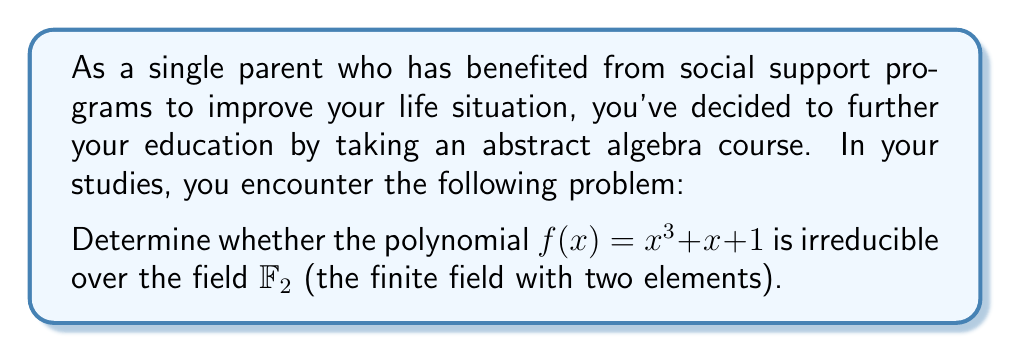Help me with this question. To determine if the polynomial $f(x) = x^3 + x + 1$ is irreducible over $\mathbb{F}_2$, we can follow these steps:

1) First, recall that a polynomial of degree 3 is reducible over a field if and only if it has a root in that field.

2) In $\mathbb{F}_2$, there are only two elements: 0 and 1. We need to check if either of these is a root of $f(x)$.

3) Let's evaluate $f(x)$ for $x = 0$ and $x = 1$:

   For $x = 0$:
   $f(0) = 0^3 + 0 + 1 = 1$

   For $x = 1$:
   $f(1) = 1^3 + 1 + 1 = 1 + 1 + 1 = 1$ (in $\mathbb{F}_2$, $1 + 1 = 0$)

4) We see that $f(x)$ is not zero for either $x = 0$ or $x = 1$. This means that $f(x)$ has no roots in $\mathbb{F}_2$.

5) Therefore, $f(x)$ cannot be factored over $\mathbb{F}_2$ and is irreducible.

Note: In $\mathbb{F}_2$, addition and multiplication are performed modulo 2. This is why $1 + 1 = 0$ in step 3.
Answer: The polynomial $f(x) = x^3 + x + 1$ is irreducible over $\mathbb{F}_2$. 